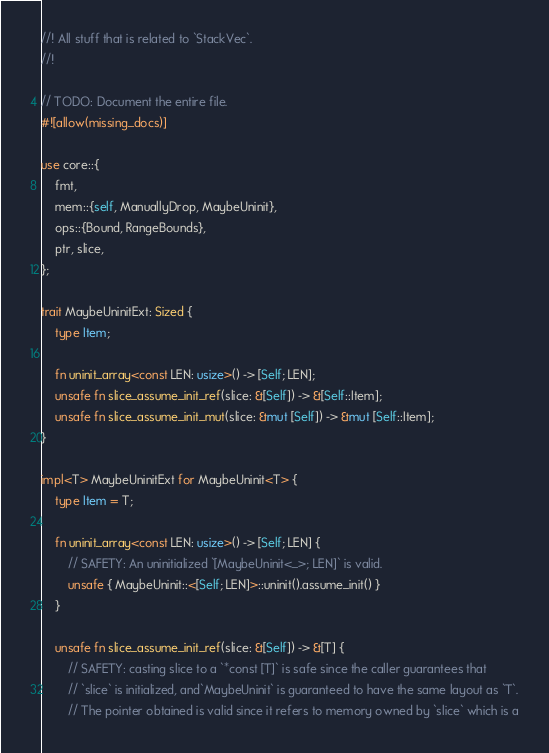Convert code to text. <code><loc_0><loc_0><loc_500><loc_500><_Rust_>//! All stuff that is related to `StackVec`.
//!

// TODO: Document the entire file.
#![allow(missing_docs)]

use core::{
    fmt,
    mem::{self, ManuallyDrop, MaybeUninit},
    ops::{Bound, RangeBounds},
    ptr, slice,
};

trait MaybeUninitExt: Sized {
    type Item;

    fn uninit_array<const LEN: usize>() -> [Self; LEN];
    unsafe fn slice_assume_init_ref(slice: &[Self]) -> &[Self::Item];
    unsafe fn slice_assume_init_mut(slice: &mut [Self]) -> &mut [Self::Item];
}

impl<T> MaybeUninitExt for MaybeUninit<T> {
    type Item = T;

    fn uninit_array<const LEN: usize>() -> [Self; LEN] {
        // SAFETY: An uninitialized `[MaybeUninit<_>; LEN]` is valid.
        unsafe { MaybeUninit::<[Self; LEN]>::uninit().assume_init() }
    }

    unsafe fn slice_assume_init_ref(slice: &[Self]) -> &[T] {
        // SAFETY: casting slice to a `*const [T]` is safe since the caller guarantees that
        // `slice` is initialized, and`MaybeUninit` is guaranteed to have the same layout as `T`.
        // The pointer obtained is valid since it refers to memory owned by `slice` which is a</code> 